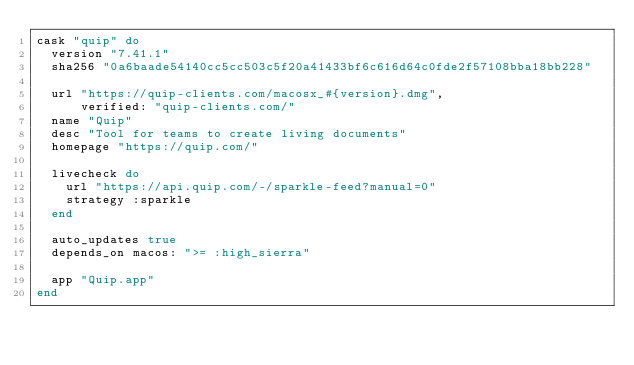Convert code to text. <code><loc_0><loc_0><loc_500><loc_500><_Ruby_>cask "quip" do
  version "7.41.1"
  sha256 "0a6baade54140cc5cc503c5f20a41433bf6c616d64c0fde2f57108bba18bb228"

  url "https://quip-clients.com/macosx_#{version}.dmg",
      verified: "quip-clients.com/"
  name "Quip"
  desc "Tool for teams to create living documents"
  homepage "https://quip.com/"

  livecheck do
    url "https://api.quip.com/-/sparkle-feed?manual=0"
    strategy :sparkle
  end

  auto_updates true
  depends_on macos: ">= :high_sierra"

  app "Quip.app"
end
</code> 